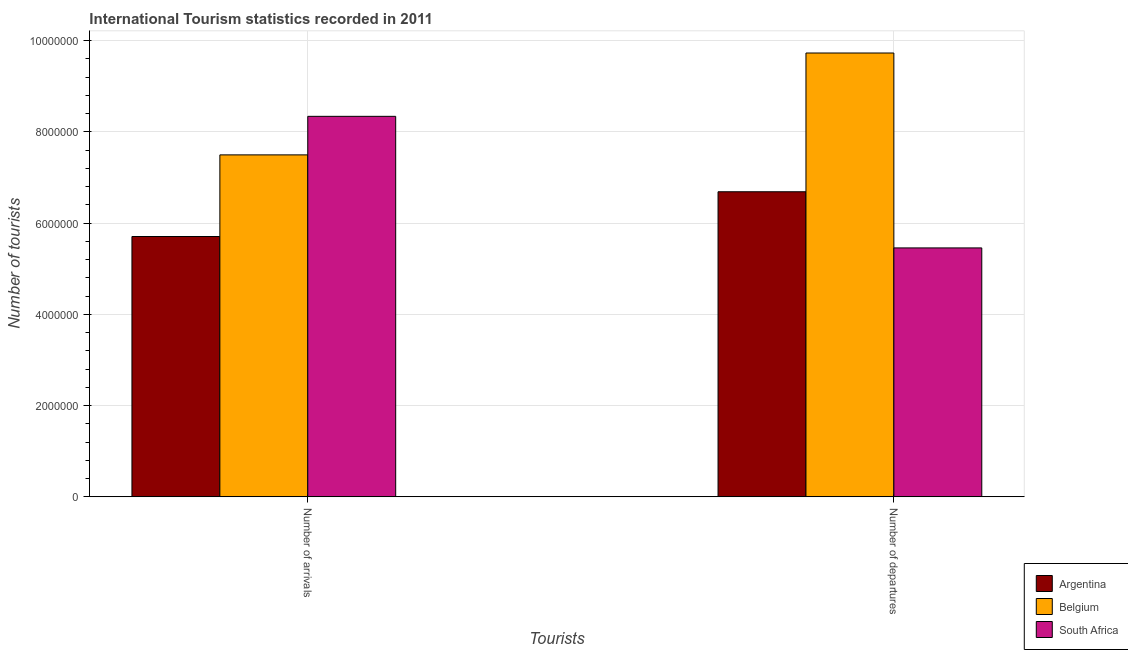How many different coloured bars are there?
Your answer should be very brief. 3. How many groups of bars are there?
Give a very brief answer. 2. Are the number of bars on each tick of the X-axis equal?
Make the answer very short. Yes. What is the label of the 1st group of bars from the left?
Provide a succinct answer. Number of arrivals. What is the number of tourist departures in South Africa?
Your answer should be compact. 5.46e+06. Across all countries, what is the maximum number of tourist arrivals?
Offer a terse response. 8.34e+06. Across all countries, what is the minimum number of tourist departures?
Your response must be concise. 5.46e+06. In which country was the number of tourist arrivals maximum?
Give a very brief answer. South Africa. In which country was the number of tourist arrivals minimum?
Provide a succinct answer. Argentina. What is the total number of tourist departures in the graph?
Provide a short and direct response. 2.19e+07. What is the difference between the number of tourist arrivals in Argentina and that in South Africa?
Ensure brevity in your answer.  -2.63e+06. What is the difference between the number of tourist arrivals in Argentina and the number of tourist departures in South Africa?
Provide a short and direct response. 2.50e+05. What is the average number of tourist departures per country?
Give a very brief answer. 7.29e+06. What is the difference between the number of tourist arrivals and number of tourist departures in Argentina?
Your answer should be compact. -9.81e+05. In how many countries, is the number of tourist departures greater than 9200000 ?
Keep it short and to the point. 1. What is the ratio of the number of tourist departures in Argentina to that in South Africa?
Your response must be concise. 1.23. What does the 2nd bar from the right in Number of arrivals represents?
Provide a succinct answer. Belgium. How many bars are there?
Your answer should be very brief. 6. What is the difference between two consecutive major ticks on the Y-axis?
Offer a very short reply. 2.00e+06. Are the values on the major ticks of Y-axis written in scientific E-notation?
Provide a succinct answer. No. Does the graph contain grids?
Your answer should be compact. Yes. Where does the legend appear in the graph?
Offer a terse response. Bottom right. What is the title of the graph?
Ensure brevity in your answer.  International Tourism statistics recorded in 2011. Does "Nicaragua" appear as one of the legend labels in the graph?
Offer a terse response. No. What is the label or title of the X-axis?
Provide a short and direct response. Tourists. What is the label or title of the Y-axis?
Make the answer very short. Number of tourists. What is the Number of tourists of Argentina in Number of arrivals?
Provide a succinct answer. 5.70e+06. What is the Number of tourists in Belgium in Number of arrivals?
Your answer should be very brief. 7.49e+06. What is the Number of tourists of South Africa in Number of arrivals?
Offer a very short reply. 8.34e+06. What is the Number of tourists in Argentina in Number of departures?
Provide a succinct answer. 6.69e+06. What is the Number of tourists in Belgium in Number of departures?
Your answer should be very brief. 9.73e+06. What is the Number of tourists of South Africa in Number of departures?
Provide a short and direct response. 5.46e+06. Across all Tourists, what is the maximum Number of tourists in Argentina?
Your answer should be very brief. 6.69e+06. Across all Tourists, what is the maximum Number of tourists of Belgium?
Your answer should be compact. 9.73e+06. Across all Tourists, what is the maximum Number of tourists in South Africa?
Your response must be concise. 8.34e+06. Across all Tourists, what is the minimum Number of tourists of Argentina?
Make the answer very short. 5.70e+06. Across all Tourists, what is the minimum Number of tourists in Belgium?
Your answer should be compact. 7.49e+06. Across all Tourists, what is the minimum Number of tourists in South Africa?
Give a very brief answer. 5.46e+06. What is the total Number of tourists of Argentina in the graph?
Offer a terse response. 1.24e+07. What is the total Number of tourists of Belgium in the graph?
Your answer should be compact. 1.72e+07. What is the total Number of tourists of South Africa in the graph?
Offer a terse response. 1.38e+07. What is the difference between the Number of tourists in Argentina in Number of arrivals and that in Number of departures?
Provide a succinct answer. -9.81e+05. What is the difference between the Number of tourists of Belgium in Number of arrivals and that in Number of departures?
Your response must be concise. -2.23e+06. What is the difference between the Number of tourists in South Africa in Number of arrivals and that in Number of departures?
Offer a terse response. 2.88e+06. What is the difference between the Number of tourists in Argentina in Number of arrivals and the Number of tourists in Belgium in Number of departures?
Ensure brevity in your answer.  -4.02e+06. What is the difference between the Number of tourists in Belgium in Number of arrivals and the Number of tourists in South Africa in Number of departures?
Give a very brief answer. 2.04e+06. What is the average Number of tourists in Argentina per Tourists?
Your answer should be compact. 6.20e+06. What is the average Number of tourists of Belgium per Tourists?
Offer a terse response. 8.61e+06. What is the average Number of tourists in South Africa per Tourists?
Your response must be concise. 6.90e+06. What is the difference between the Number of tourists of Argentina and Number of tourists of Belgium in Number of arrivals?
Make the answer very short. -1.79e+06. What is the difference between the Number of tourists in Argentina and Number of tourists in South Africa in Number of arrivals?
Keep it short and to the point. -2.63e+06. What is the difference between the Number of tourists in Belgium and Number of tourists in South Africa in Number of arrivals?
Keep it short and to the point. -8.45e+05. What is the difference between the Number of tourists in Argentina and Number of tourists in Belgium in Number of departures?
Offer a terse response. -3.04e+06. What is the difference between the Number of tourists of Argentina and Number of tourists of South Africa in Number of departures?
Keep it short and to the point. 1.23e+06. What is the difference between the Number of tourists in Belgium and Number of tourists in South Africa in Number of departures?
Provide a short and direct response. 4.27e+06. What is the ratio of the Number of tourists in Argentina in Number of arrivals to that in Number of departures?
Keep it short and to the point. 0.85. What is the ratio of the Number of tourists in Belgium in Number of arrivals to that in Number of departures?
Give a very brief answer. 0.77. What is the ratio of the Number of tourists in South Africa in Number of arrivals to that in Number of departures?
Your answer should be compact. 1.53. What is the difference between the highest and the second highest Number of tourists in Argentina?
Keep it short and to the point. 9.81e+05. What is the difference between the highest and the second highest Number of tourists in Belgium?
Provide a succinct answer. 2.23e+06. What is the difference between the highest and the second highest Number of tourists of South Africa?
Your answer should be very brief. 2.88e+06. What is the difference between the highest and the lowest Number of tourists of Argentina?
Make the answer very short. 9.81e+05. What is the difference between the highest and the lowest Number of tourists in Belgium?
Provide a succinct answer. 2.23e+06. What is the difference between the highest and the lowest Number of tourists in South Africa?
Keep it short and to the point. 2.88e+06. 